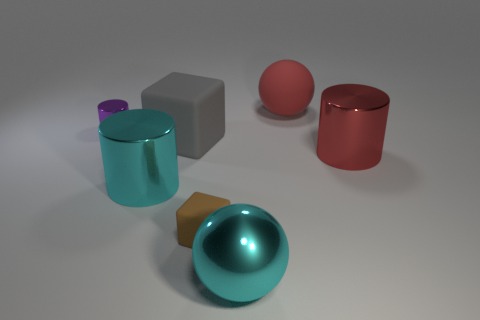Add 3 big rubber spheres. How many objects exist? 10 Subtract all cylinders. How many objects are left? 4 Add 1 large gray cubes. How many large gray cubes are left? 2 Add 7 big purple metal objects. How many big purple metal objects exist? 7 Subtract 0 green balls. How many objects are left? 7 Subtract all red cylinders. Subtract all matte objects. How many objects are left? 3 